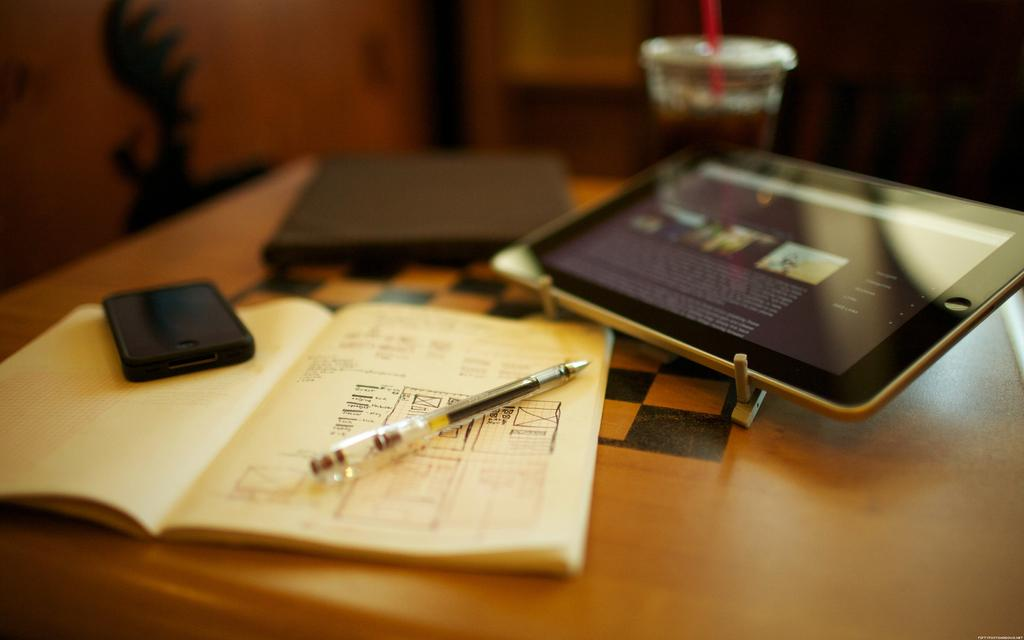What piece of furniture is present in the image? There is a table in the image. What electronic device is on the table? There is an iPad on the table. What type of reading material is on the table? There is a book on the table. What writing instrument is on the table? There is a pen on the table. What communication device is on the table? There is a mobile phone on the table. Where is the cobweb located in the image? There is no cobweb present in the image. What type of magic is being performed in the image? There is no magic or magical activity depicted in the image. 